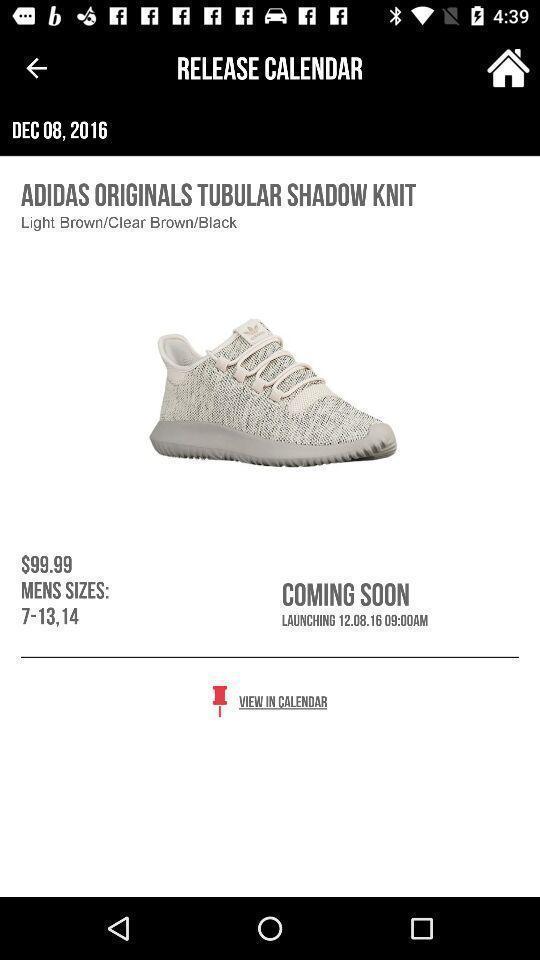Provide a textual representation of this image. Page displays a product in shopping app. 